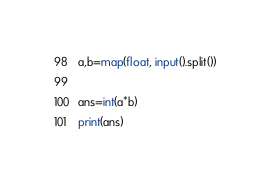<code> <loc_0><loc_0><loc_500><loc_500><_Python_>a,b=map(float, input().split())

ans=int(a*b)
print(ans)</code> 